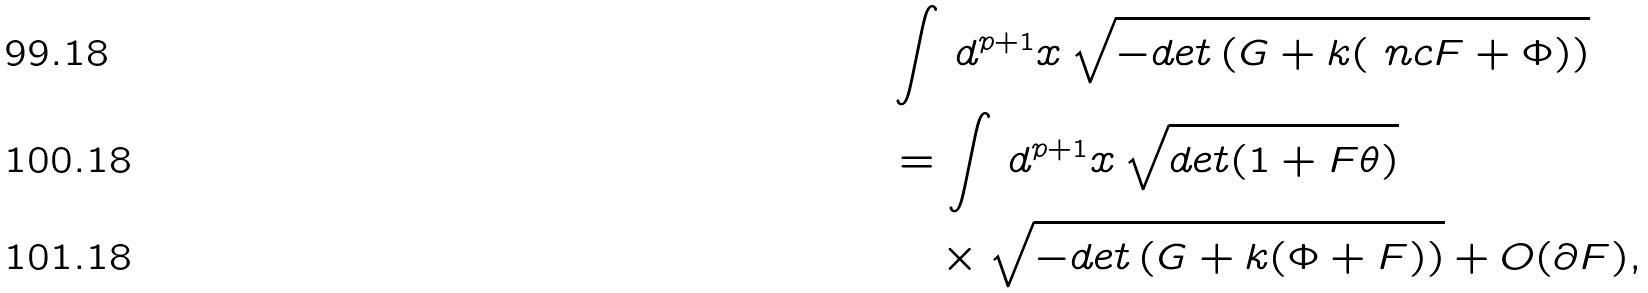Convert formula to latex. <formula><loc_0><loc_0><loc_500><loc_500>& \int \, d ^ { p + 1 } x \, \sqrt { - d e t \left ( G + k ( \ n c { F } + \Phi ) \right ) } \\ & = \int \, d ^ { p + 1 } x \, \sqrt { d e t ( 1 + F \theta ) } \\ & \quad \times \sqrt { - d e t \left ( G + k ( \Phi + F ) \right ) } + O ( \partial F ) ,</formula> 